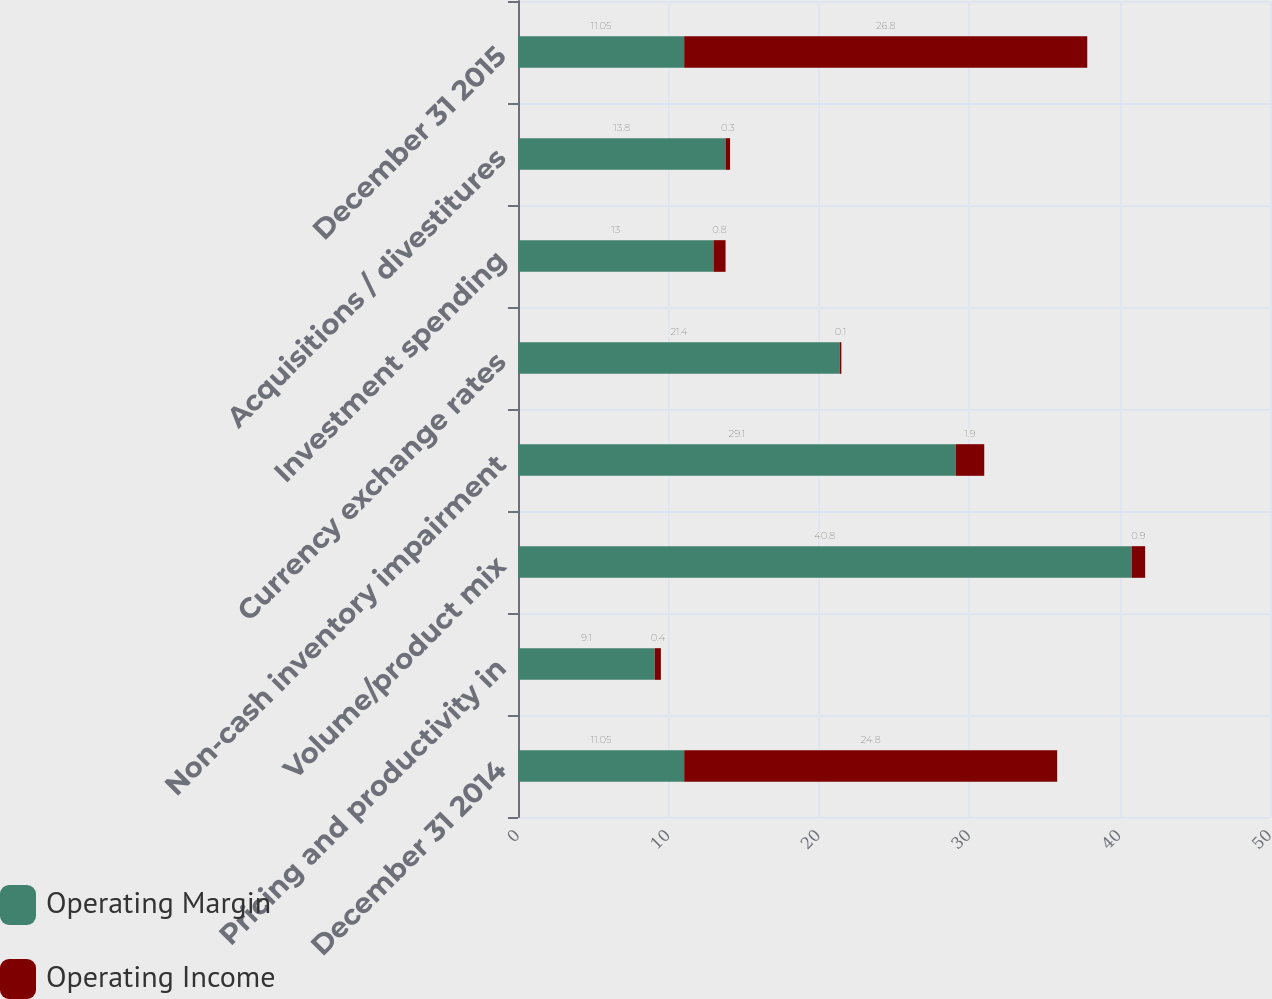<chart> <loc_0><loc_0><loc_500><loc_500><stacked_bar_chart><ecel><fcel>December 31 2014<fcel>Pricing and productivity in<fcel>Volume/product mix<fcel>Non-cash inventory impairment<fcel>Currency exchange rates<fcel>Investment spending<fcel>Acquisitions / divestitures<fcel>December 31 2015<nl><fcel>Operating Margin<fcel>11.05<fcel>9.1<fcel>40.8<fcel>29.1<fcel>21.4<fcel>13<fcel>13.8<fcel>11.05<nl><fcel>Operating Income<fcel>24.8<fcel>0.4<fcel>0.9<fcel>1.9<fcel>0.1<fcel>0.8<fcel>0.3<fcel>26.8<nl></chart> 